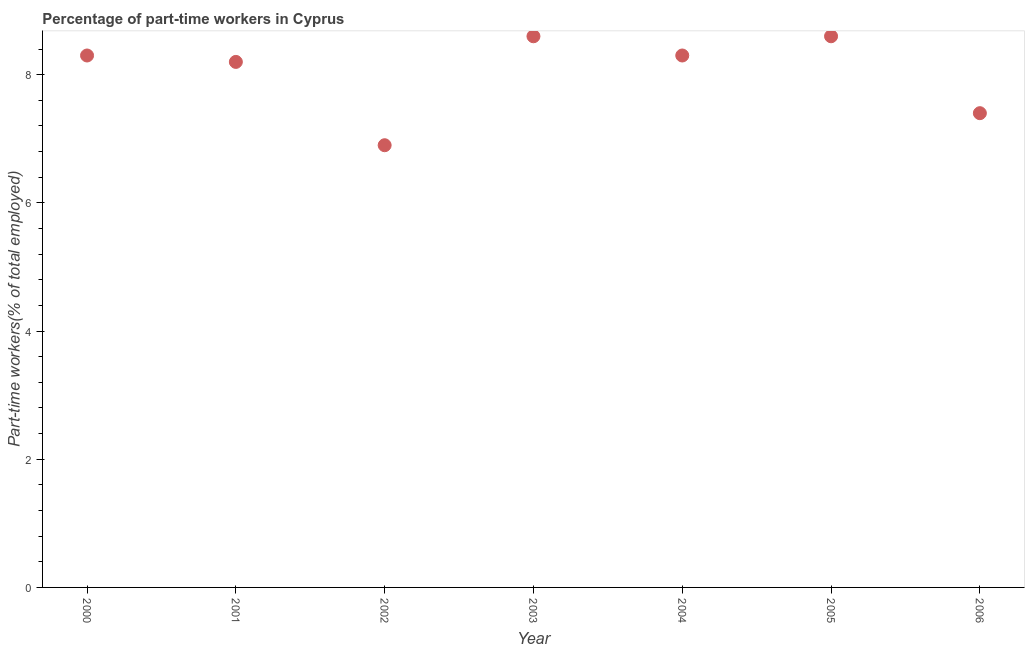What is the percentage of part-time workers in 2005?
Your answer should be compact. 8.6. Across all years, what is the maximum percentage of part-time workers?
Give a very brief answer. 8.6. Across all years, what is the minimum percentage of part-time workers?
Provide a succinct answer. 6.9. What is the sum of the percentage of part-time workers?
Your answer should be compact. 56.3. What is the difference between the percentage of part-time workers in 2001 and 2002?
Give a very brief answer. 1.3. What is the average percentage of part-time workers per year?
Give a very brief answer. 8.04. What is the median percentage of part-time workers?
Your answer should be compact. 8.3. In how many years, is the percentage of part-time workers greater than 1.2000000000000002 %?
Your response must be concise. 7. What is the ratio of the percentage of part-time workers in 2002 to that in 2006?
Keep it short and to the point. 0.93. What is the difference between the highest and the second highest percentage of part-time workers?
Give a very brief answer. 0. Is the sum of the percentage of part-time workers in 2000 and 2005 greater than the maximum percentage of part-time workers across all years?
Offer a terse response. Yes. What is the difference between the highest and the lowest percentage of part-time workers?
Your answer should be compact. 1.7. In how many years, is the percentage of part-time workers greater than the average percentage of part-time workers taken over all years?
Offer a very short reply. 5. Does the percentage of part-time workers monotonically increase over the years?
Your response must be concise. No. How many years are there in the graph?
Make the answer very short. 7. What is the difference between two consecutive major ticks on the Y-axis?
Make the answer very short. 2. Are the values on the major ticks of Y-axis written in scientific E-notation?
Give a very brief answer. No. Does the graph contain grids?
Give a very brief answer. No. What is the title of the graph?
Offer a very short reply. Percentage of part-time workers in Cyprus. What is the label or title of the Y-axis?
Your answer should be compact. Part-time workers(% of total employed). What is the Part-time workers(% of total employed) in 2000?
Provide a succinct answer. 8.3. What is the Part-time workers(% of total employed) in 2001?
Keep it short and to the point. 8.2. What is the Part-time workers(% of total employed) in 2002?
Keep it short and to the point. 6.9. What is the Part-time workers(% of total employed) in 2003?
Provide a short and direct response. 8.6. What is the Part-time workers(% of total employed) in 2004?
Keep it short and to the point. 8.3. What is the Part-time workers(% of total employed) in 2005?
Provide a short and direct response. 8.6. What is the Part-time workers(% of total employed) in 2006?
Your answer should be compact. 7.4. What is the difference between the Part-time workers(% of total employed) in 2000 and 2001?
Your response must be concise. 0.1. What is the difference between the Part-time workers(% of total employed) in 2000 and 2002?
Provide a short and direct response. 1.4. What is the difference between the Part-time workers(% of total employed) in 2000 and 2004?
Offer a terse response. 0. What is the difference between the Part-time workers(% of total employed) in 2000 and 2005?
Your response must be concise. -0.3. What is the difference between the Part-time workers(% of total employed) in 2001 and 2004?
Provide a succinct answer. -0.1. What is the difference between the Part-time workers(% of total employed) in 2001 and 2006?
Offer a very short reply. 0.8. What is the difference between the Part-time workers(% of total employed) in 2002 and 2004?
Your response must be concise. -1.4. What is the difference between the Part-time workers(% of total employed) in 2002 and 2005?
Give a very brief answer. -1.7. What is the difference between the Part-time workers(% of total employed) in 2003 and 2004?
Your answer should be very brief. 0.3. What is the difference between the Part-time workers(% of total employed) in 2003 and 2005?
Give a very brief answer. 0. What is the difference between the Part-time workers(% of total employed) in 2004 and 2006?
Keep it short and to the point. 0.9. What is the ratio of the Part-time workers(% of total employed) in 2000 to that in 2001?
Provide a short and direct response. 1.01. What is the ratio of the Part-time workers(% of total employed) in 2000 to that in 2002?
Keep it short and to the point. 1.2. What is the ratio of the Part-time workers(% of total employed) in 2000 to that in 2003?
Your answer should be compact. 0.96. What is the ratio of the Part-time workers(% of total employed) in 2000 to that in 2005?
Your response must be concise. 0.96. What is the ratio of the Part-time workers(% of total employed) in 2000 to that in 2006?
Your answer should be compact. 1.12. What is the ratio of the Part-time workers(% of total employed) in 2001 to that in 2002?
Your answer should be very brief. 1.19. What is the ratio of the Part-time workers(% of total employed) in 2001 to that in 2003?
Your response must be concise. 0.95. What is the ratio of the Part-time workers(% of total employed) in 2001 to that in 2005?
Provide a succinct answer. 0.95. What is the ratio of the Part-time workers(% of total employed) in 2001 to that in 2006?
Your answer should be compact. 1.11. What is the ratio of the Part-time workers(% of total employed) in 2002 to that in 2003?
Keep it short and to the point. 0.8. What is the ratio of the Part-time workers(% of total employed) in 2002 to that in 2004?
Keep it short and to the point. 0.83. What is the ratio of the Part-time workers(% of total employed) in 2002 to that in 2005?
Your answer should be very brief. 0.8. What is the ratio of the Part-time workers(% of total employed) in 2002 to that in 2006?
Your answer should be very brief. 0.93. What is the ratio of the Part-time workers(% of total employed) in 2003 to that in 2004?
Provide a short and direct response. 1.04. What is the ratio of the Part-time workers(% of total employed) in 2003 to that in 2005?
Ensure brevity in your answer.  1. What is the ratio of the Part-time workers(% of total employed) in 2003 to that in 2006?
Keep it short and to the point. 1.16. What is the ratio of the Part-time workers(% of total employed) in 2004 to that in 2005?
Keep it short and to the point. 0.96. What is the ratio of the Part-time workers(% of total employed) in 2004 to that in 2006?
Your answer should be very brief. 1.12. What is the ratio of the Part-time workers(% of total employed) in 2005 to that in 2006?
Offer a terse response. 1.16. 